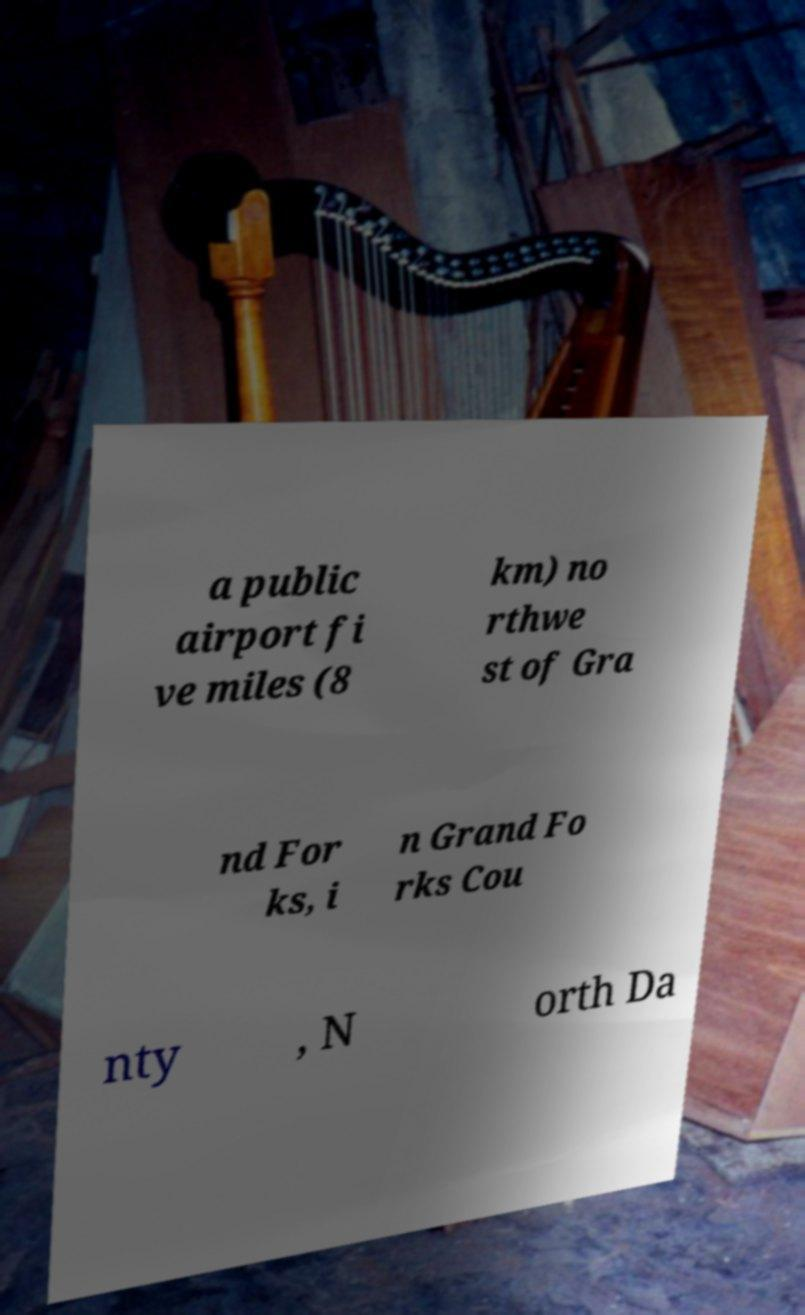For documentation purposes, I need the text within this image transcribed. Could you provide that? a public airport fi ve miles (8 km) no rthwe st of Gra nd For ks, i n Grand Fo rks Cou nty , N orth Da 